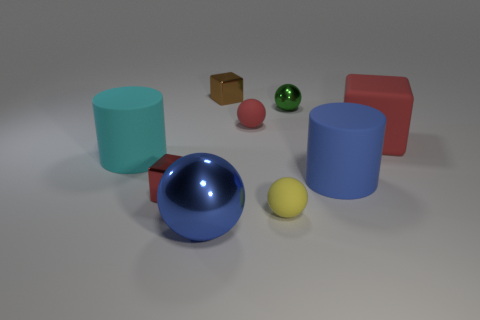There is another block that is the same color as the big block; what is its material?
Offer a very short reply. Metal. How many brown spheres are the same material as the small yellow sphere?
Provide a succinct answer. 0. The big sphere that is the same material as the green object is what color?
Provide a short and direct response. Blue. The tiny red rubber object has what shape?
Your answer should be very brief. Sphere. What is the large cylinder that is left of the big blue ball made of?
Your answer should be compact. Rubber. Are there any objects that have the same color as the big block?
Your answer should be compact. Yes. What is the shape of the red shiny object that is the same size as the brown block?
Provide a succinct answer. Cube. There is a big matte cylinder on the left side of the tiny brown object; what is its color?
Offer a very short reply. Cyan. There is a small ball to the right of the tiny yellow rubber thing; is there a large cyan rubber thing that is in front of it?
Your response must be concise. Yes. How many things are either small spheres that are left of the green thing or large rubber things?
Your answer should be compact. 5. 